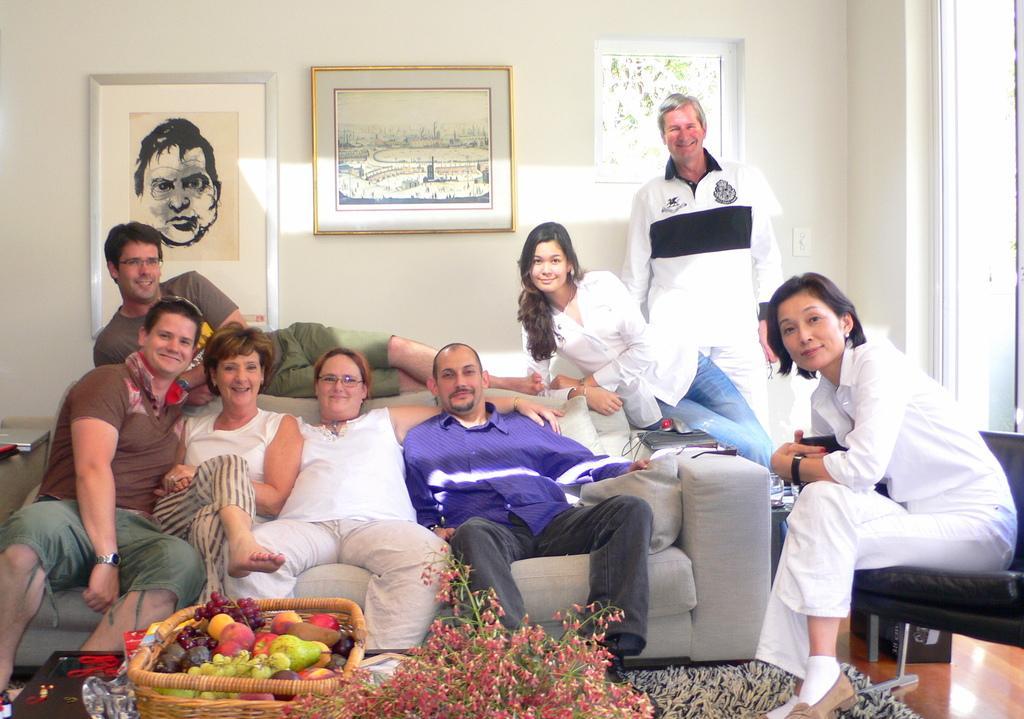Can you describe this image briefly? In this image, we can see people and some are sitting on the sofa and there is a lady sitting on the chair and holding an objects and we can see a man lying. In the background, there are frames on the wall and we can see fruits, a basket, plants and some other objects on the stands. 